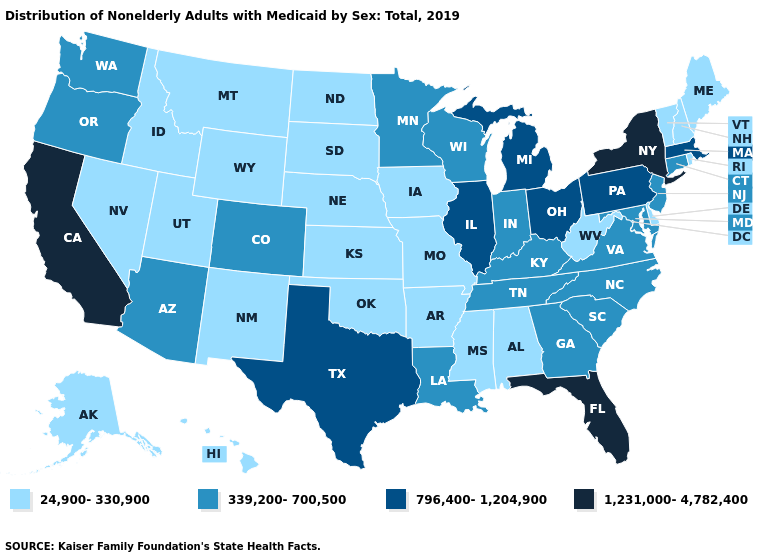Name the states that have a value in the range 24,900-330,900?
Give a very brief answer. Alabama, Alaska, Arkansas, Delaware, Hawaii, Idaho, Iowa, Kansas, Maine, Mississippi, Missouri, Montana, Nebraska, Nevada, New Hampshire, New Mexico, North Dakota, Oklahoma, Rhode Island, South Dakota, Utah, Vermont, West Virginia, Wyoming. What is the value of Nevada?
Answer briefly. 24,900-330,900. Name the states that have a value in the range 1,231,000-4,782,400?
Keep it brief. California, Florida, New York. Does Florida have the highest value in the USA?
Short answer required. Yes. What is the lowest value in the USA?
Answer briefly. 24,900-330,900. Does Connecticut have a higher value than Hawaii?
Quick response, please. Yes. What is the value of Rhode Island?
Write a very short answer. 24,900-330,900. Which states have the lowest value in the South?
Write a very short answer. Alabama, Arkansas, Delaware, Mississippi, Oklahoma, West Virginia. What is the lowest value in the USA?
Keep it brief. 24,900-330,900. What is the value of Florida?
Short answer required. 1,231,000-4,782,400. Does the first symbol in the legend represent the smallest category?
Quick response, please. Yes. Among the states that border Maine , which have the lowest value?
Concise answer only. New Hampshire. Does Ohio have a lower value than New Mexico?
Answer briefly. No. Name the states that have a value in the range 796,400-1,204,900?
Keep it brief. Illinois, Massachusetts, Michigan, Ohio, Pennsylvania, Texas. Does Alabama have the lowest value in the South?
Keep it brief. Yes. 